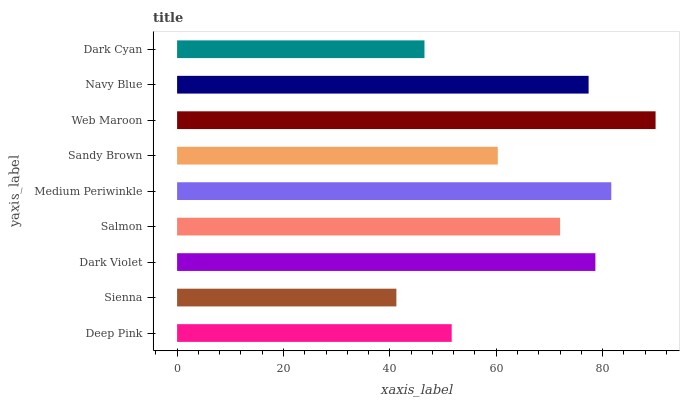Is Sienna the minimum?
Answer yes or no. Yes. Is Web Maroon the maximum?
Answer yes or no. Yes. Is Dark Violet the minimum?
Answer yes or no. No. Is Dark Violet the maximum?
Answer yes or no. No. Is Dark Violet greater than Sienna?
Answer yes or no. Yes. Is Sienna less than Dark Violet?
Answer yes or no. Yes. Is Sienna greater than Dark Violet?
Answer yes or no. No. Is Dark Violet less than Sienna?
Answer yes or no. No. Is Salmon the high median?
Answer yes or no. Yes. Is Salmon the low median?
Answer yes or no. Yes. Is Web Maroon the high median?
Answer yes or no. No. Is Web Maroon the low median?
Answer yes or no. No. 